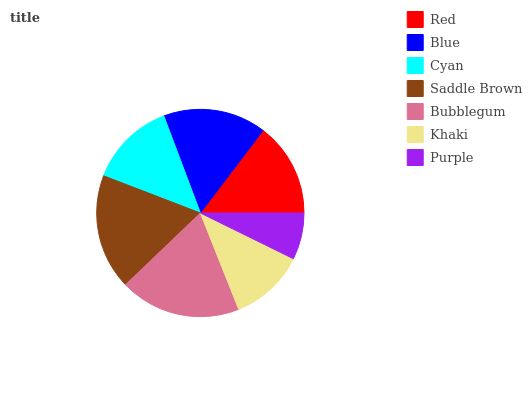Is Purple the minimum?
Answer yes or no. Yes. Is Bubblegum the maximum?
Answer yes or no. Yes. Is Blue the minimum?
Answer yes or no. No. Is Blue the maximum?
Answer yes or no. No. Is Blue greater than Red?
Answer yes or no. Yes. Is Red less than Blue?
Answer yes or no. Yes. Is Red greater than Blue?
Answer yes or no. No. Is Blue less than Red?
Answer yes or no. No. Is Red the high median?
Answer yes or no. Yes. Is Red the low median?
Answer yes or no. Yes. Is Bubblegum the high median?
Answer yes or no. No. Is Khaki the low median?
Answer yes or no. No. 